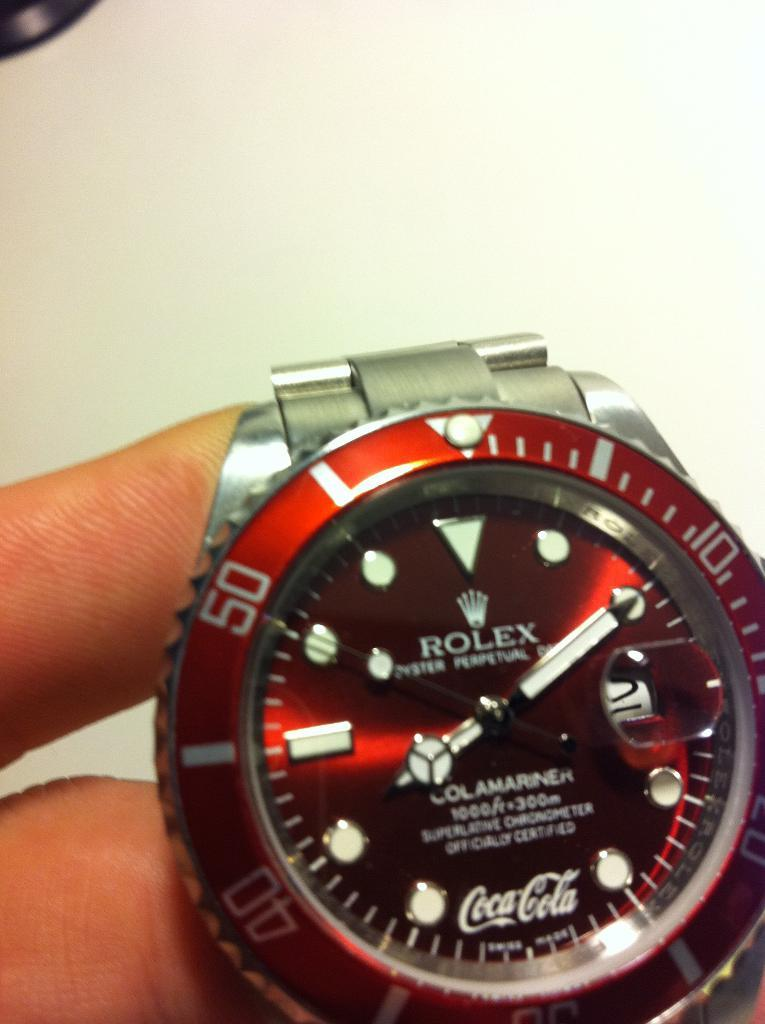<image>
Offer a succinct explanation of the picture presented. A person is holding a red and silver Rolex Oyster. 